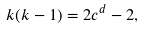Convert formula to latex. <formula><loc_0><loc_0><loc_500><loc_500>k ( k - 1 ) = 2 c ^ { d } - 2 ,</formula> 